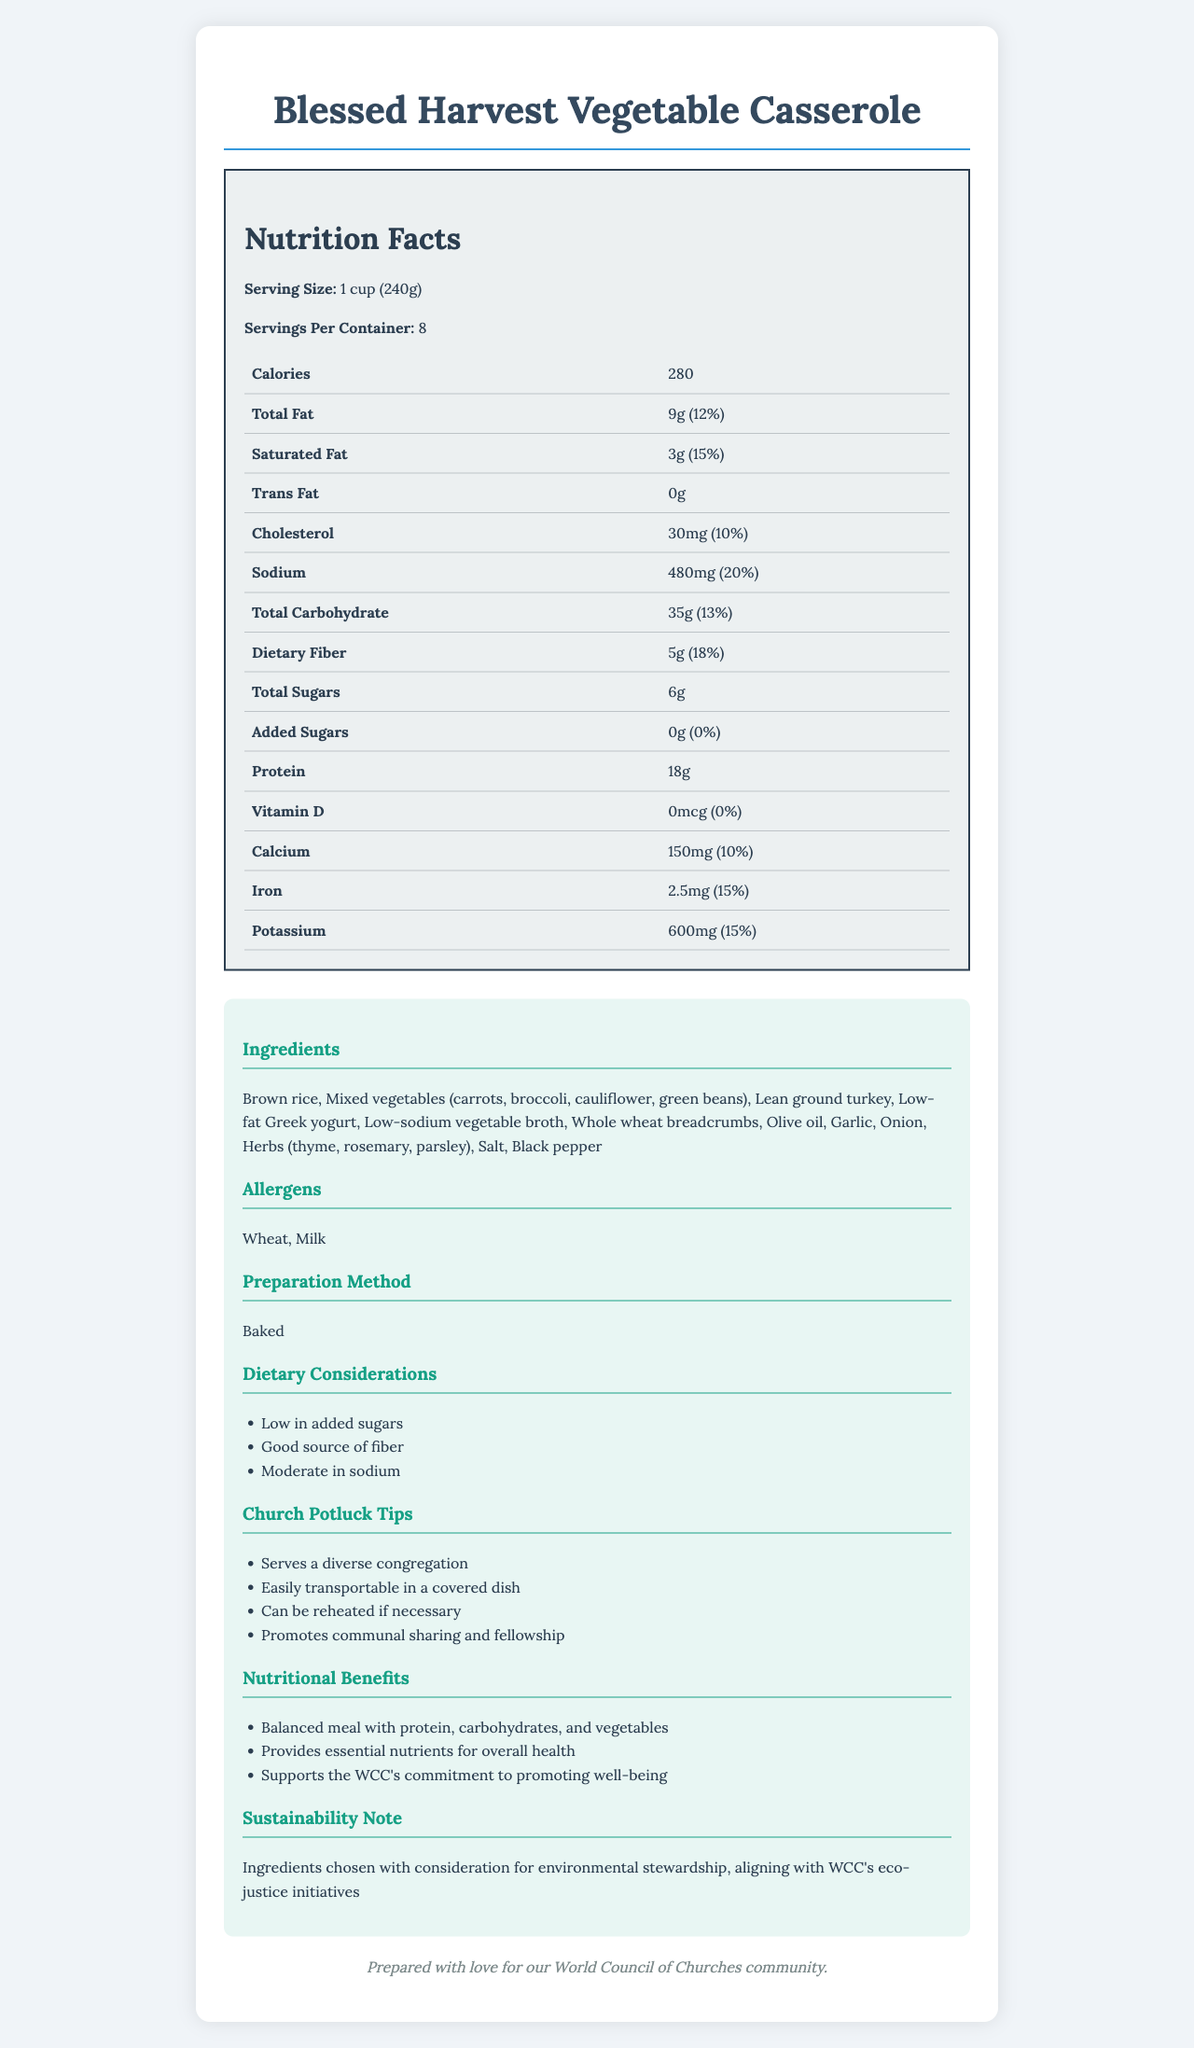What is the serving size for the Blessed Harvest Vegetable Casserole? The serving size is clearly indicated in the Nutrition Facts section of the document.
Answer: 1 cup (240g) How many servings are in the container? The servings per container are listed in the Nutrition Facts section as 8.
Answer: 8 How many calories are in one serving? The document lists the calorie content as 280 per serving.
Answer: 280 What is the amount of total fat in one serving? The total fat content per serving is given as 9g in the Nutrition Facts.
Answer: 9g What is the amount of dietary fiber in one serving? The dietary fiber content per serving is listed as 5g in the document.
Answer: 5g What allergens are present in the Blessed Harvest Vegetable Casserole? The allergens are listed in the "Allergens" section of the document.
Answer: Wheat, Milk What is the main preparation method for the casserole? The document states that the preparation method is "Baked".
Answer: Baked What are the dietary considerations mentioned for the casserole? (Choose all that apply) A. Low in added sugars B. Good source of fiber C. Gluten-free D. Low sodium The casserole is described as low in added sugars and a good source of fiber.
Answer: A, B Which ingredient is not listed in the ingredients section? A. Brown rice B. Mixed vegetables C. Chicken D. Olive oil Chicken is not listed among the ingredients.
Answer: C Does the Blessed Harvest Vegetable Casserole contain added sugars? The section on added sugars indicates that the casserole contains 0g of added sugars.
Answer: No Is the Blessed Harvest Vegetable Casserole easily transportable for church potlucks? The church potluck tips mention that it is easily transportable in a covered dish.
Answer: Yes Summarize the main idea of the document. The document includes various sections that give a detailed overview of the casserole's nutrition facts, ingredients, and additional considerations for serving it at church potlucks.
Answer: The document provides the nutritional information, ingredients, allergens, preparation method, dietary considerations, and benefits of the Blessed Harvest Vegetable Casserole. It also includes tips for church potlucks, emphasizing its health benefits, transportability, and alignment with the WCC's values on stewardship. Which environmental initiative does the casserole align with according to the document? The sustainability note mentions that the ingredients were chosen with consideration for environmental stewardship, aligning with the WCC's eco-justice initiatives.
Answer: WCC's eco-justice initiatives How is the casserole described in terms of nutritional benefits? The nutritional benefits section lists these three main points to describe the nutritional value of the casserole.
Answer: Balanced meal with protein, carbohydrates, and vegetables; Provides essential nutrients for overall health; Supports the WCC's commitment to promoting well-being What is the vitamin D content in one serving of the Blessed Harvest Vegetable Casserole? The document lists the vitamin D content as 0mcg in the Nutrition Facts section.
Answer: 0mcg How much calcium is in each serving? The calcium content per serving is listed as 150mg in the document.
Answer: 150mg How many grams of protein are there in one serving? A. 10g B. 15g C. 18g D. 21g The protein content is listed as 18g per serving in the Nutrition Facts section.
Answer: C What is the main source of protein in the Blessed Harvest Vegetable Casserole? The list of ingredients includes lean ground turkey, which is the main source of protein.
Answer: Lean ground turkey What percentage of the daily value of sodium does one serving of this casserole provide? The Nutrition Facts section indicates that one serving provides 20% of the daily value of sodium.
Answer: 20% Which vitamin or mineral has the highest daily value percentage in the casserole? At 15%, potassium has the highest daily value percentage as listed in the Nutrition Facts section.
Answer: Potassium How many total grams of carbohydrates are there in one serving? The total carbohydrate content is listed as 35g per serving in the document.
Answer: 35g What is the amount of saturated fat in one serving of the casserole? The Nutrition Facts section indicates that there are 3g of saturated fat per serving.
Answer: 3g Can the exact recipe for Blessed Harvest Vegetable Casserole be determined from this document? The document provides ingredients and preparation methods but does not include detailed steps or quantities for making the casserole.
Answer: No 